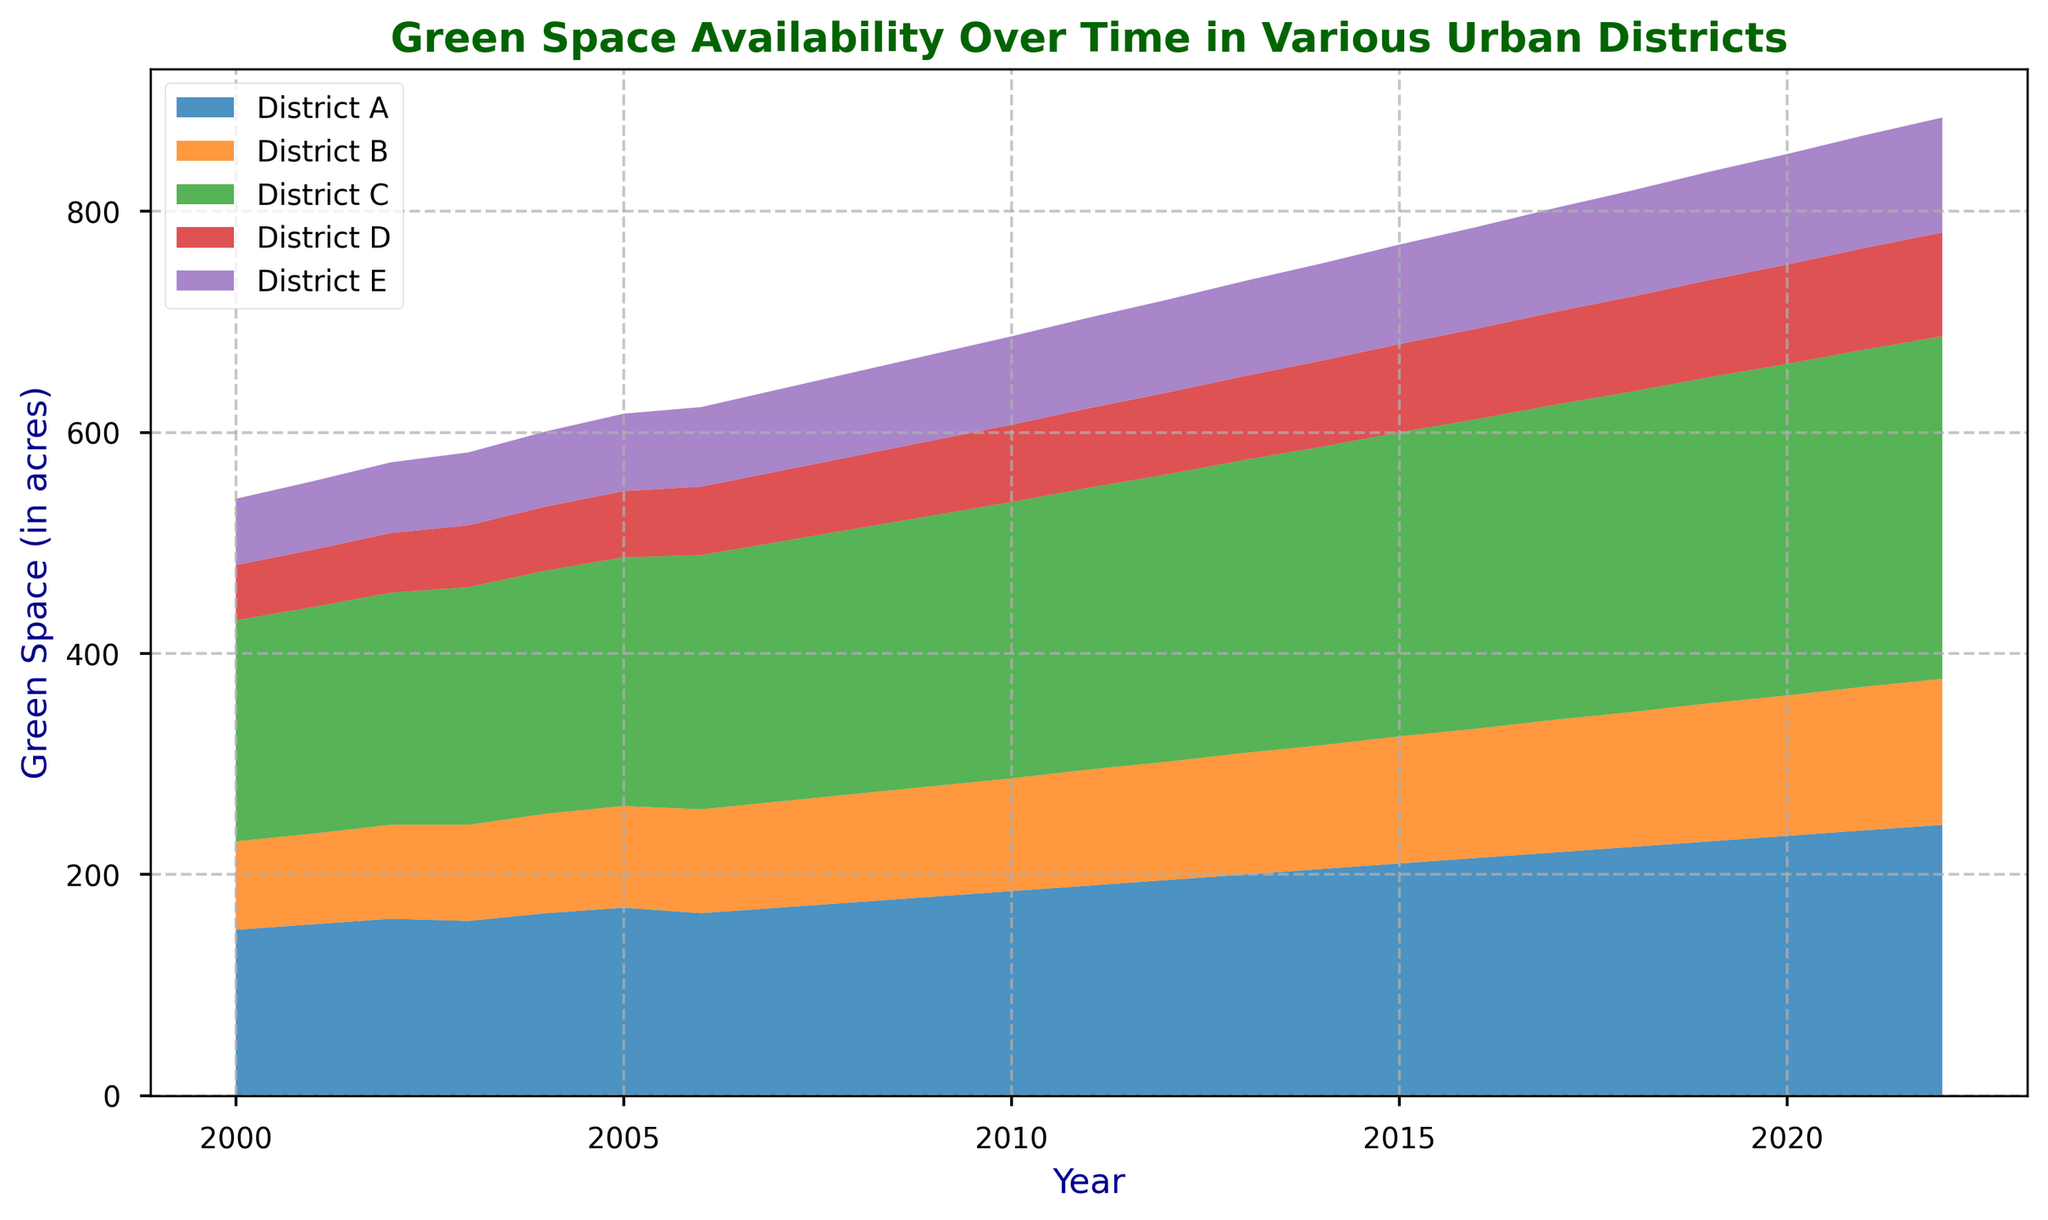What is the general trend of green space availability in District B from 2000 to 2022? The stackplot shows an increasing trend for all districts, including District B, where the green space availability rises from 80 acres in 2000 to 132 acres in 2022. This is visualized by the upward slope of the area associated with District B.
Answer: Increasing Between which years did District E experience the fastest growth in green space availability? By observing the steepness of the visual area representing District E, the steepest segment appears to be between 2000 and 2005, as this portion of the chart shows the sharpest increase.
Answer: 2000 to 2005 How does the green space availability in 2010 compare between District A and District C? By comparing the heights of the corresponding segments in the stackplot for 2010, District A has 185 acres, while District C has 250 acres. Thus, District C has more green space than District A in 2010.
Answer: District C has more Which district had the smallest amount of green space in 2022? The visual area for each district at the year 2022 shows that District D has the smallest segment, indicating it has the least green space, standing at 94 acres.
Answer: District D What is the total green space available across all districts in the year 2005? Sum the green space of all districts for 2005: District A (170) + District B (92) + District C (225) + District D (60) + District E (70) = 617 acres.
Answer: 617 acres In which year does District A surpass 200 acres of green space for the first time? By following the visual representation of District A, it surpasses 200 acres in 2013 where its green space reaches exactly 200 acres.
Answer: 2013 By how many acres did the green space in District C increase from 2000 to 2022? Calculate the difference: Green space in District C in 2022 (310 acres) minus green space in 2000 (200 acres) equals an increase of 110 acres.
Answer: 110 acres What is the common trend observed in green space availability for all districts collectively over the years? The visual representation of the stack areas for all districts shows a consistent upward trend, indicating an overall increase in green space availability across all districts.
Answer: Increasing trend How much green space was available in District B and District C combined in 2015? Sum the green space of District B and District C for 2015: District B (115) + District C (275) = 390 acres.
Answer: 390 acres 